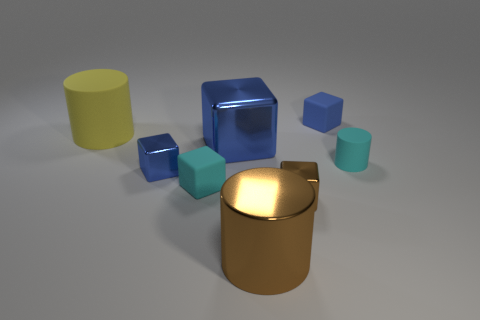What number of tiny things are either blue matte cubes or blue shiny cylinders?
Provide a short and direct response. 1. Are there any cyan matte objects of the same shape as the small brown thing?
Keep it short and to the point. Yes. Is the large yellow object the same shape as the large blue metallic object?
Offer a terse response. No. What is the color of the rubber block that is behind the small cyan rubber object right of the brown metallic cylinder?
Offer a very short reply. Blue. The rubber cylinder that is the same size as the blue rubber cube is what color?
Make the answer very short. Cyan. What number of rubber objects are either small purple blocks or cyan cylinders?
Offer a terse response. 1. There is a small matte thing that is behind the big yellow rubber cylinder; what number of tiny blue metal blocks are to the right of it?
Your answer should be compact. 0. There is a metal thing that is the same color as the large block; what is its size?
Offer a terse response. Small. How many things are big red cylinders or big cylinders that are in front of the big blue shiny thing?
Your answer should be very brief. 1. Are there any cyan blocks made of the same material as the brown block?
Your response must be concise. No. 